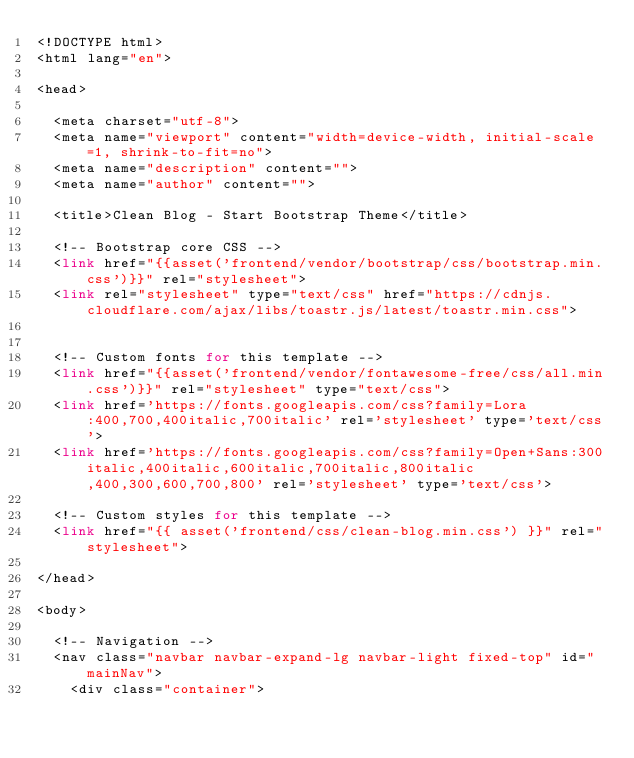<code> <loc_0><loc_0><loc_500><loc_500><_PHP_><!DOCTYPE html>
<html lang="en">

<head>

  <meta charset="utf-8">
  <meta name="viewport" content="width=device-width, initial-scale=1, shrink-to-fit=no">
  <meta name="description" content="">
  <meta name="author" content="">

  <title>Clean Blog - Start Bootstrap Theme</title>

  <!-- Bootstrap core CSS -->
  <link href="{{asset('frontend/vendor/bootstrap/css/bootstrap.min.css')}}" rel="stylesheet">
  <link rel="stylesheet" type="text/css" href="https://cdnjs.cloudflare.com/ajax/libs/toastr.js/latest/toastr.min.css">
  

  <!-- Custom fonts for this template -->
  <link href="{{asset('frontend/vendor/fontawesome-free/css/all.min.css')}}" rel="stylesheet" type="text/css">
  <link href='https://fonts.googleapis.com/css?family=Lora:400,700,400italic,700italic' rel='stylesheet' type='text/css'>
  <link href='https://fonts.googleapis.com/css?family=Open+Sans:300italic,400italic,600italic,700italic,800italic,400,300,600,700,800' rel='stylesheet' type='text/css'>

  <!-- Custom styles for this template -->
  <link href="{{ asset('frontend/css/clean-blog.min.css') }}" rel="stylesheet">

</head>

<body>

  <!-- Navigation -->
  <nav class="navbar navbar-expand-lg navbar-light fixed-top" id="mainNav">
    <div class="container"></code> 